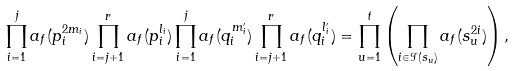Convert formula to latex. <formula><loc_0><loc_0><loc_500><loc_500>\prod _ { i = 1 } ^ { j } a _ { f } ( p _ { i } ^ { 2 m _ { i } } ) \prod _ { i = j + 1 } ^ { r } a _ { f } ( p _ { i } ^ { l _ { i } } ) \prod _ { i = 1 } ^ { j } a _ { f } ( q _ { i } ^ { m _ { i } ^ { \prime } } ) \prod _ { i = j + 1 } ^ { r } a _ { f } ( q _ { i } ^ { l ^ { \prime } _ { i } } ) = \prod _ { u = 1 } ^ { t } \left ( \prod _ { i \in \mathcal { I } ( s _ { u } ) } a _ { f } ( s _ { u } ^ { 2 i } ) \right ) ,</formula> 